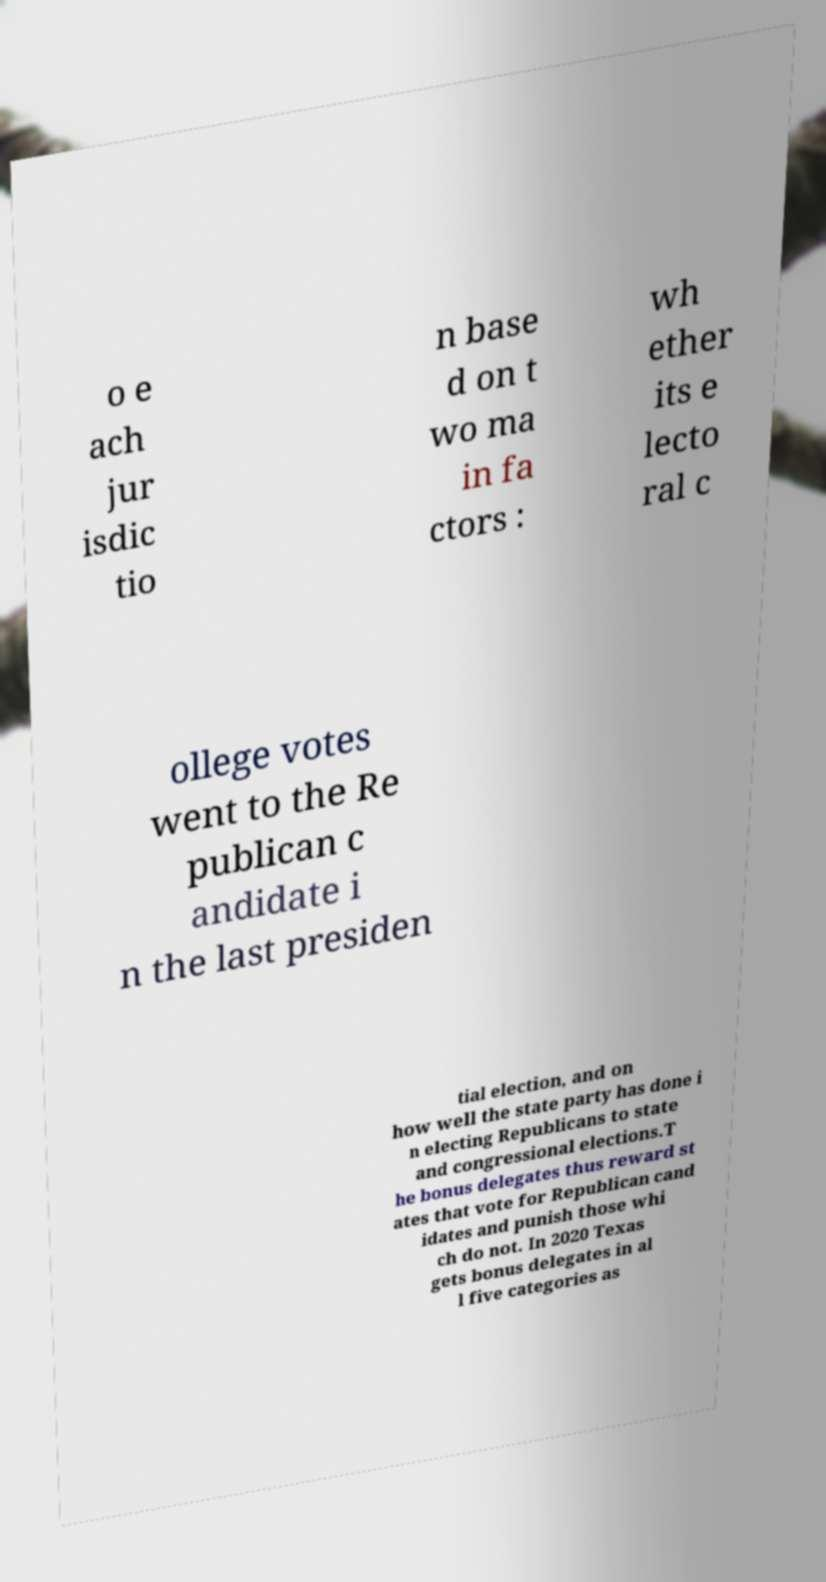There's text embedded in this image that I need extracted. Can you transcribe it verbatim? o e ach jur isdic tio n base d on t wo ma in fa ctors : wh ether its e lecto ral c ollege votes went to the Re publican c andidate i n the last presiden tial election, and on how well the state party has done i n electing Republicans to state and congressional elections.T he bonus delegates thus reward st ates that vote for Republican cand idates and punish those whi ch do not. In 2020 Texas gets bonus delegates in al l five categories as 